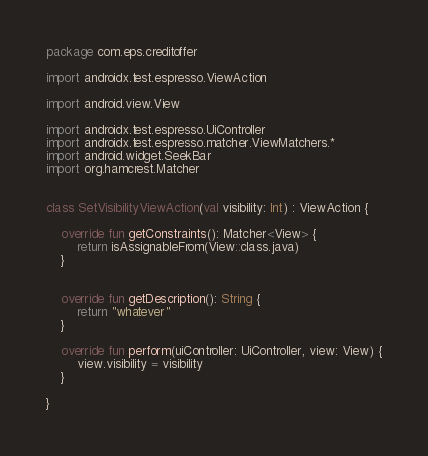<code> <loc_0><loc_0><loc_500><loc_500><_Kotlin_>package com.eps.creditoffer

import androidx.test.espresso.ViewAction

import android.view.View

import androidx.test.espresso.UiController
import androidx.test.espresso.matcher.ViewMatchers.*
import android.widget.SeekBar
import org.hamcrest.Matcher


class SetVisibilityViewAction(val visibility: Int) : ViewAction {

    override fun getConstraints(): Matcher<View> {
        return isAssignableFrom(View::class.java)
    }


    override fun getDescription(): String {
        return "whatever"
    }

    override fun perform(uiController: UiController, view: View) {
        view.visibility = visibility
    }

}</code> 